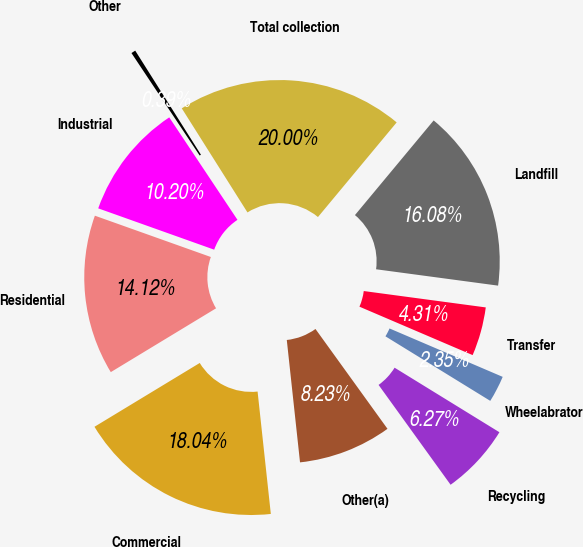<chart> <loc_0><loc_0><loc_500><loc_500><pie_chart><fcel>Commercial<fcel>Residential<fcel>Industrial<fcel>Other<fcel>Total collection<fcel>Landfill<fcel>Transfer<fcel>Wheelabrator<fcel>Recycling<fcel>Other(a)<nl><fcel>18.04%<fcel>14.12%<fcel>10.2%<fcel>0.39%<fcel>20.0%<fcel>16.08%<fcel>4.31%<fcel>2.35%<fcel>6.27%<fcel>8.23%<nl></chart> 